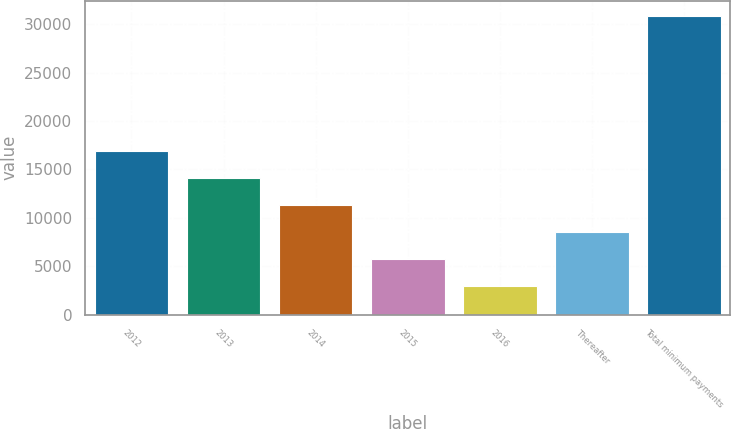Convert chart to OTSL. <chart><loc_0><loc_0><loc_500><loc_500><bar_chart><fcel>2012<fcel>2013<fcel>2014<fcel>2015<fcel>2016<fcel>Thereafter<fcel>Total minimum payments<nl><fcel>16905<fcel>14114.8<fcel>11324.6<fcel>5744.2<fcel>2954<fcel>8534.4<fcel>30856<nl></chart> 